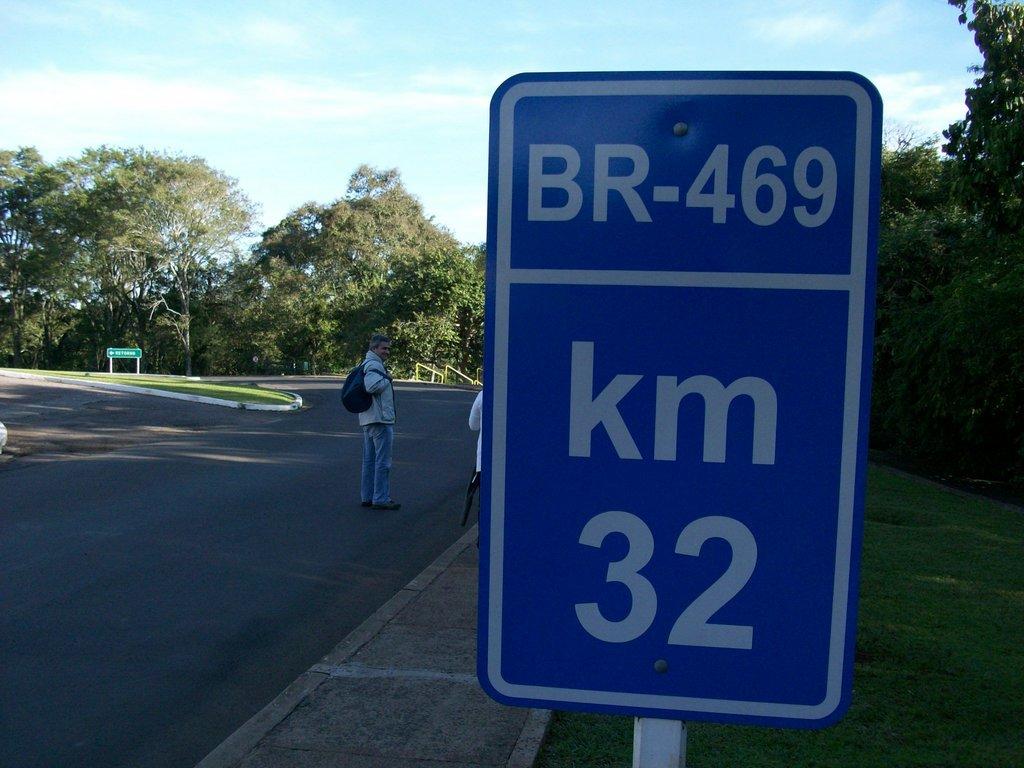How many kilometers does the sign say?
Your response must be concise. 32. What marker is this?
Your response must be concise. Br-469. 